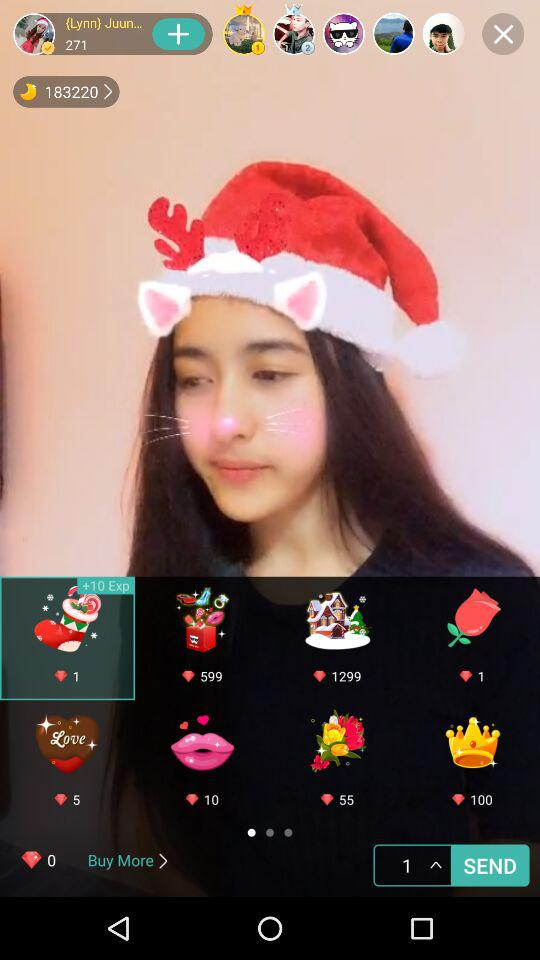How many diamonds do I have? You have 0 diamonds. 